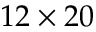<formula> <loc_0><loc_0><loc_500><loc_500>1 2 \times 2 0</formula> 